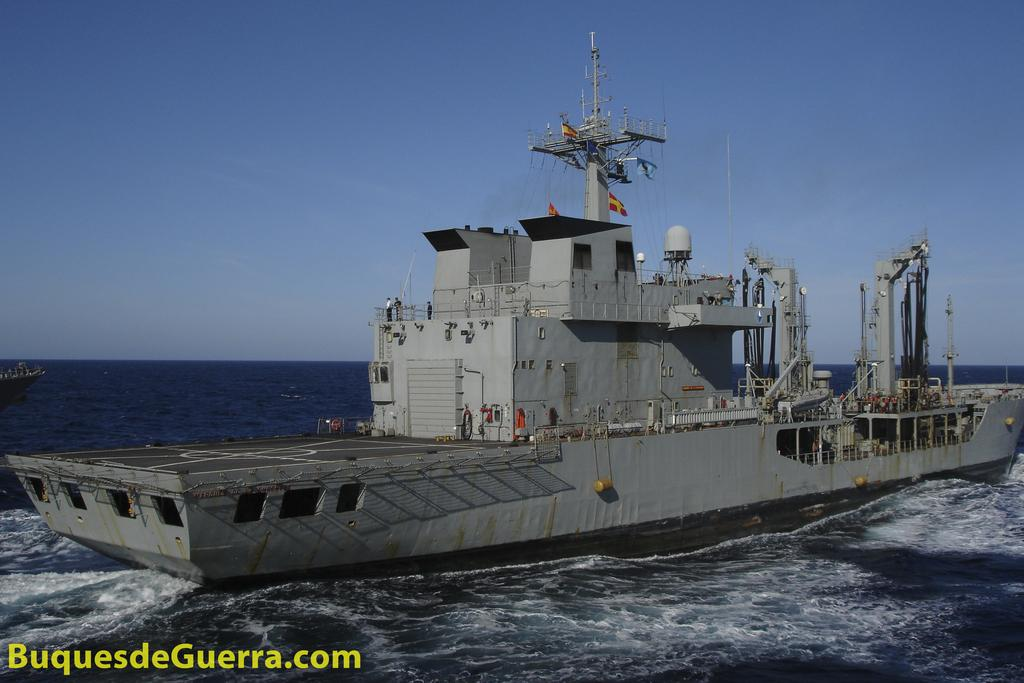What is the main subject of the image? The main subject of the image is a big ship. Where is the ship located in the image? The ship is in a river. What type of peace symbol can be seen on the ship in the image? There is no peace symbol present on the ship in the image. What type of food is being served on the ship in the image? There is no indication of food or any food-related activities in the image. 